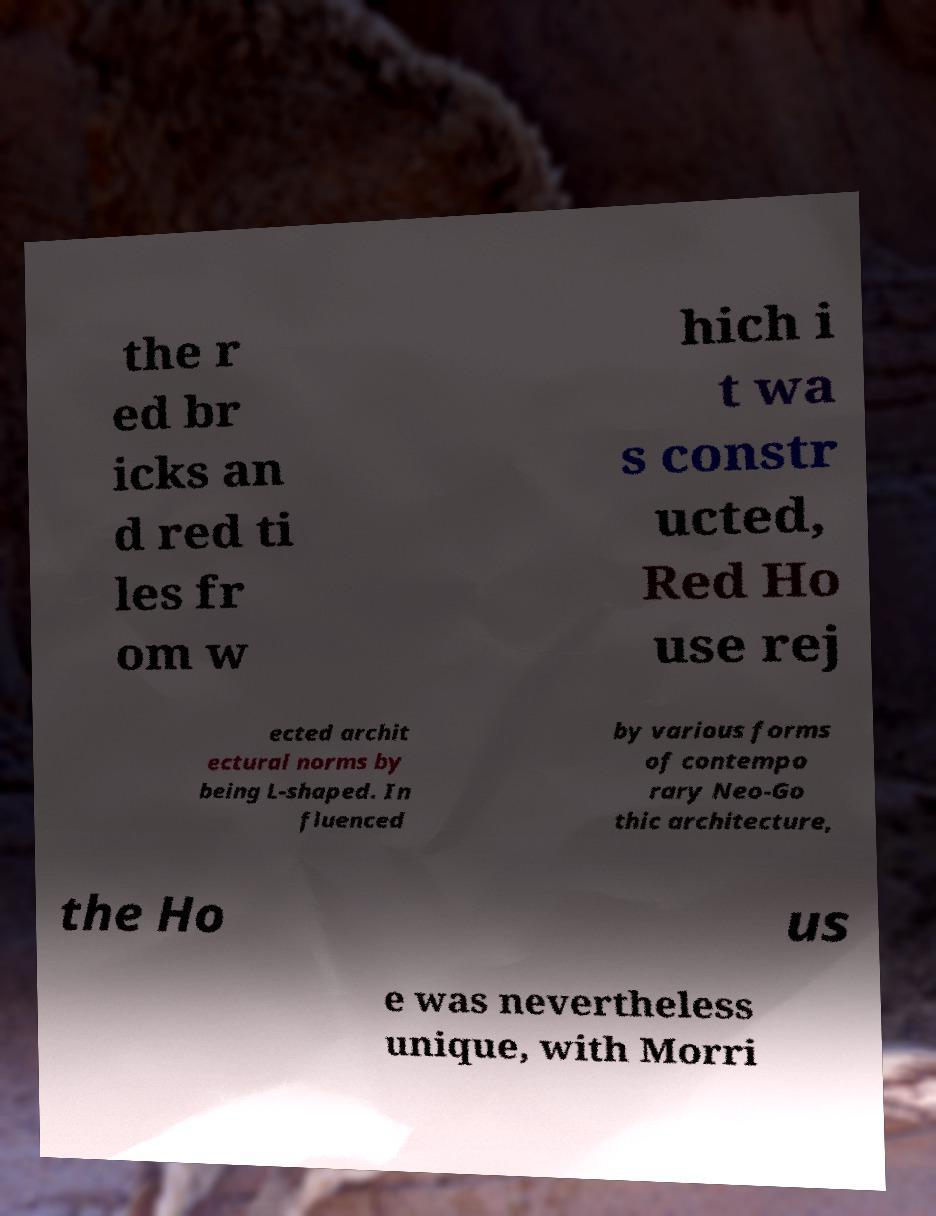Please identify and transcribe the text found in this image. the r ed br icks an d red ti les fr om w hich i t wa s constr ucted, Red Ho use rej ected archit ectural norms by being L-shaped. In fluenced by various forms of contempo rary Neo-Go thic architecture, the Ho us e was nevertheless unique, with Morri 